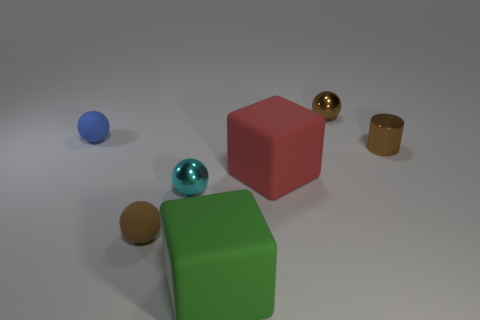Subtract all blue spheres. How many spheres are left? 3 Add 3 purple matte objects. How many objects exist? 10 Subtract all blue balls. How many balls are left? 3 Subtract 1 cylinders. How many cylinders are left? 0 Subtract 1 blue balls. How many objects are left? 6 Subtract all cylinders. How many objects are left? 6 Subtract all yellow cubes. Subtract all gray balls. How many cubes are left? 2 Subtract all purple cubes. How many brown balls are left? 2 Subtract all big gray metallic cylinders. Subtract all tiny cylinders. How many objects are left? 6 Add 2 tiny cyan balls. How many tiny cyan balls are left? 3 